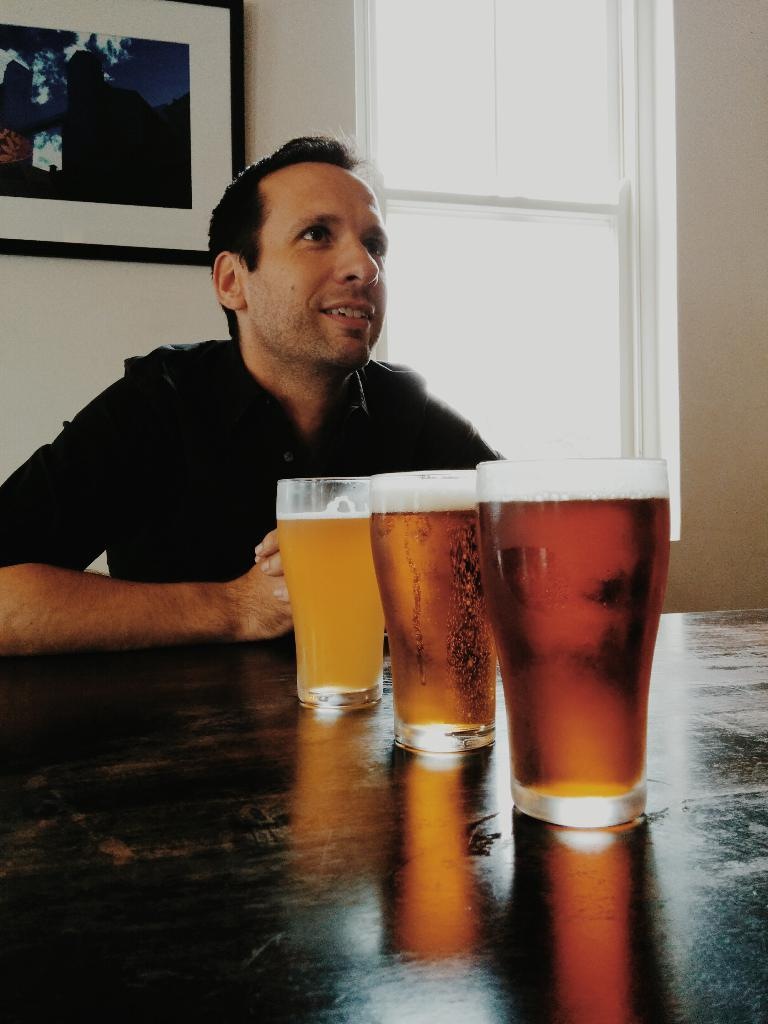What is the person in the image doing? There is a person sitting in the image. What can be seen on the surface in front of the person? There are glasses with liquid on the surface. What is visible on the wall in the background? There is a wall with a photo frame in the background. What is another feature visible in the background? There is a window in the background. What type of battle is taking place outside the window in the image? There is no battle visible in the image; the window shows a regular outdoor scene. How many planes can be seen flying outside the window in the image? There are no planes visible in the image; only the window and its view are present. 